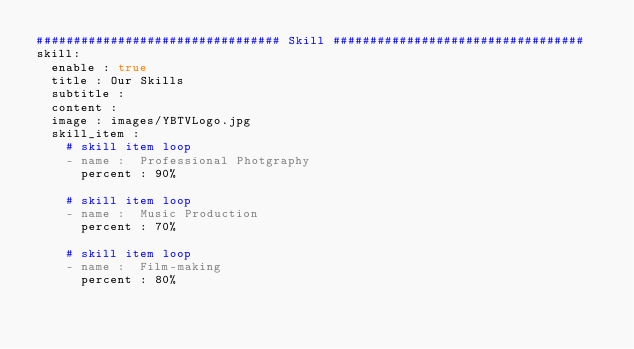<code> <loc_0><loc_0><loc_500><loc_500><_YAML_>################################# Skill ##################################
skill:
  enable : true
  title : Our Skills
  subtitle : 
  content : 
  image : images/YBTVLogo.jpg
  skill_item :
    # skill item loop
    - name :  Professional Photgraphy
      percent : 90%
      
    # skill item loop
    - name :  Music Production
      percent : 70%
      
    # skill item loop
    - name :  Film-making
      percent : 80%
      
    
</code> 